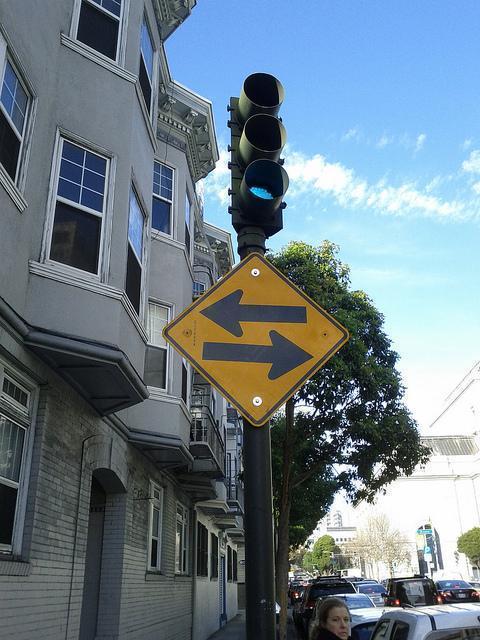Where does the woman stand at?
Choose the right answer from the provided options to respond to the question.
Options: Front yard, highway, intersection, porch. Intersection. 